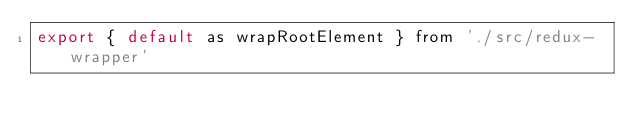Convert code to text. <code><loc_0><loc_0><loc_500><loc_500><_JavaScript_>export { default as wrapRootElement } from './src/redux-wrapper'</code> 